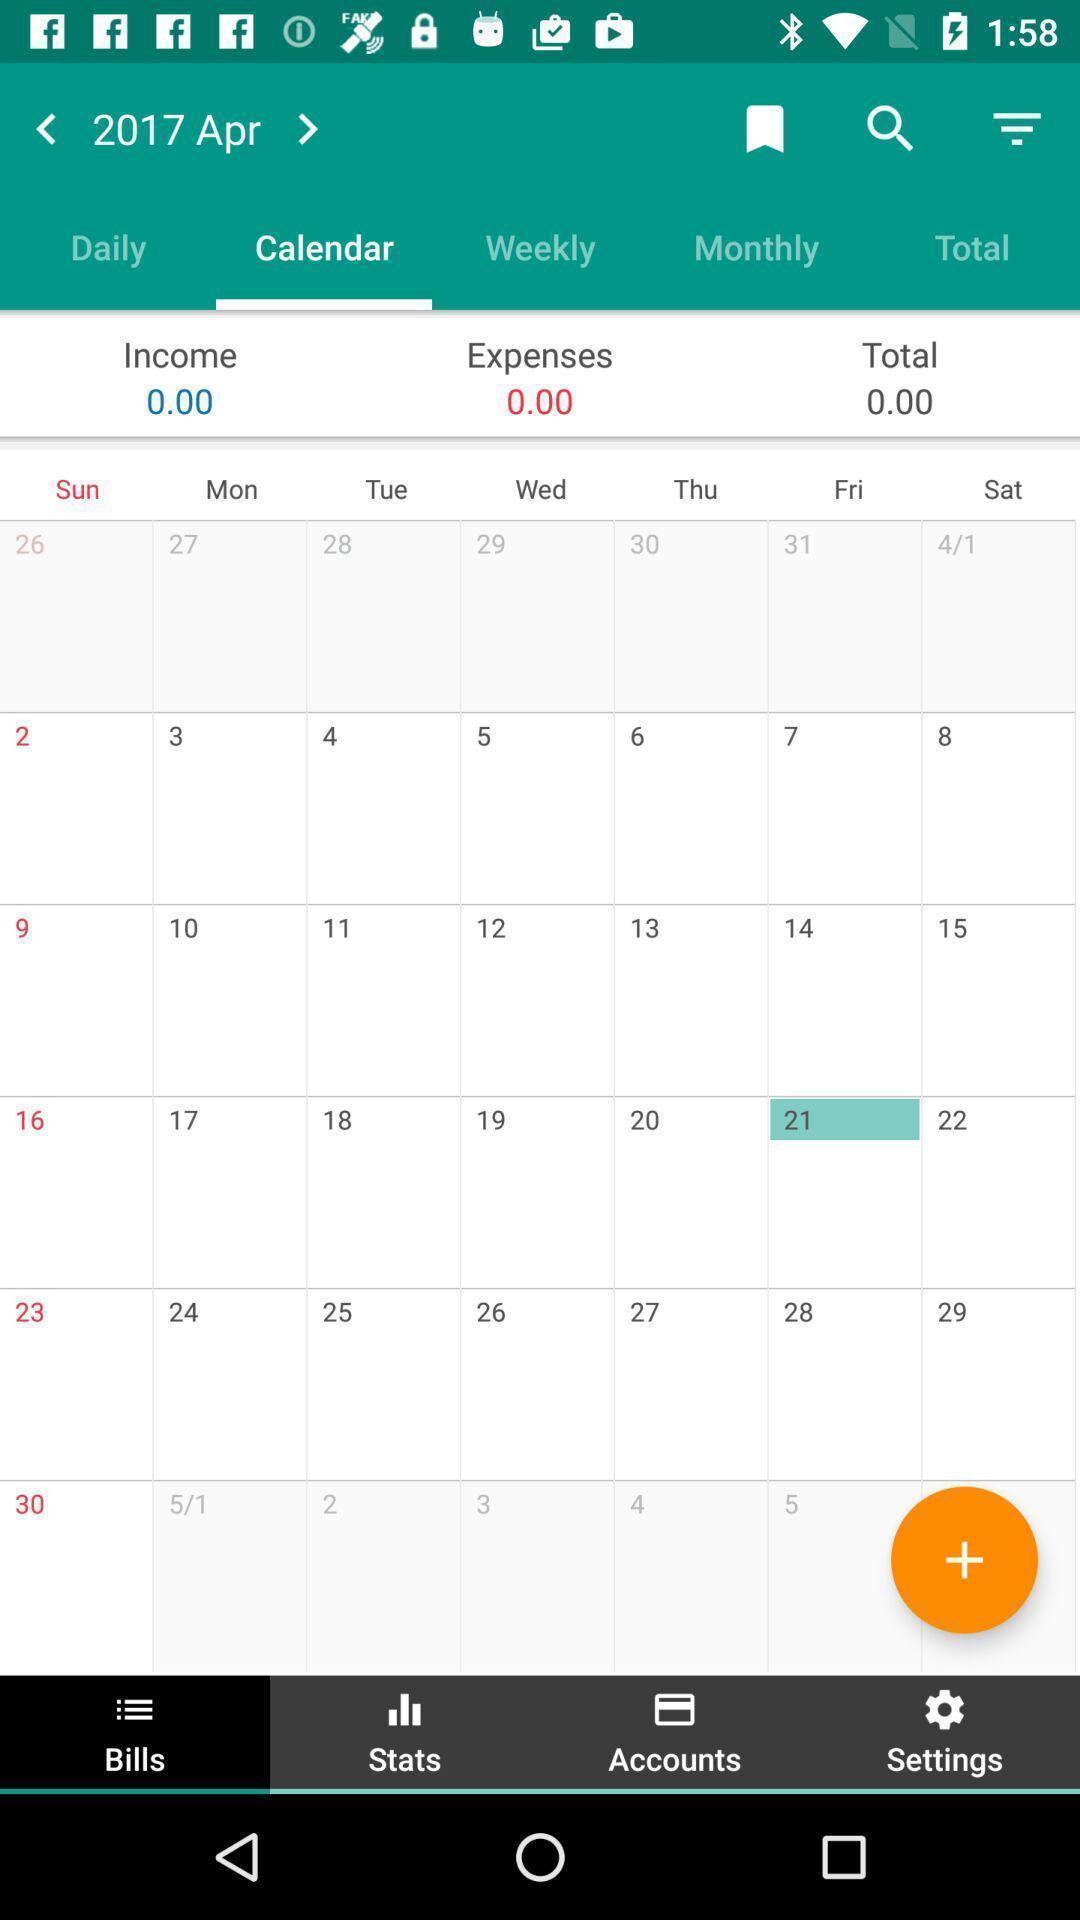Tell me what you see in this picture. Page displaying the various options of the calendar. 